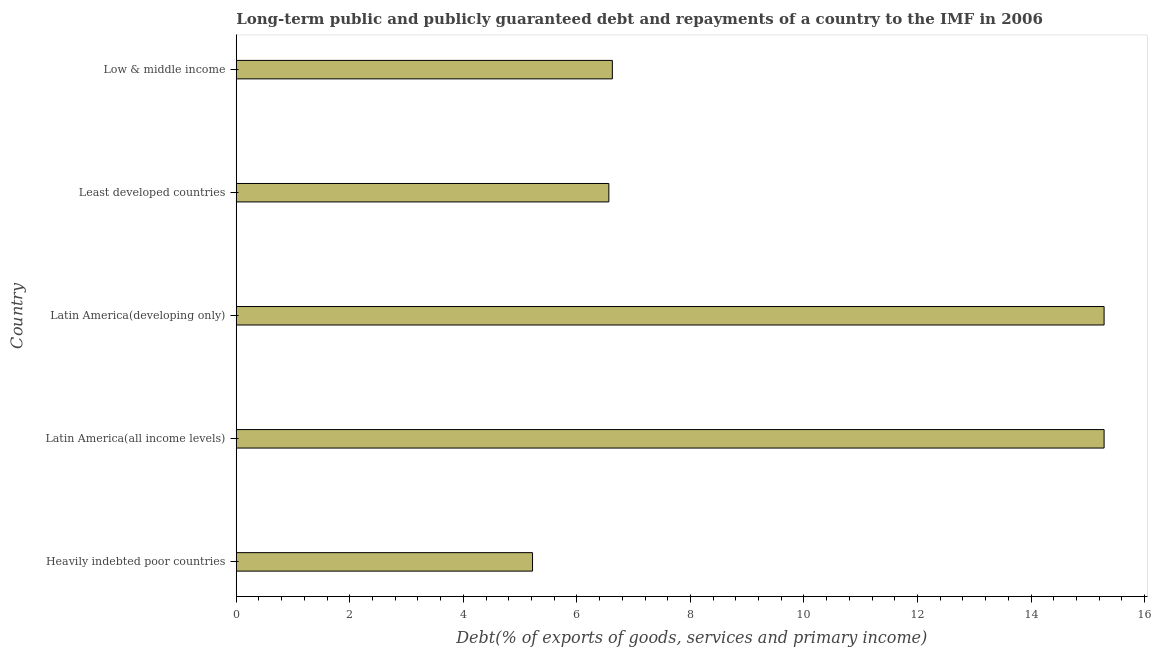What is the title of the graph?
Your answer should be compact. Long-term public and publicly guaranteed debt and repayments of a country to the IMF in 2006. What is the label or title of the X-axis?
Make the answer very short. Debt(% of exports of goods, services and primary income). What is the debt service in Heavily indebted poor countries?
Your answer should be very brief. 5.22. Across all countries, what is the maximum debt service?
Ensure brevity in your answer.  15.29. Across all countries, what is the minimum debt service?
Make the answer very short. 5.22. In which country was the debt service maximum?
Offer a terse response. Latin America(all income levels). In which country was the debt service minimum?
Your response must be concise. Heavily indebted poor countries. What is the sum of the debt service?
Give a very brief answer. 48.98. What is the average debt service per country?
Provide a short and direct response. 9.8. What is the median debt service?
Your answer should be compact. 6.62. What is the ratio of the debt service in Heavily indebted poor countries to that in Latin America(developing only)?
Keep it short and to the point. 0.34. Is the sum of the debt service in Heavily indebted poor countries and Latin America(all income levels) greater than the maximum debt service across all countries?
Ensure brevity in your answer.  Yes. What is the difference between the highest and the lowest debt service?
Ensure brevity in your answer.  10.07. In how many countries, is the debt service greater than the average debt service taken over all countries?
Ensure brevity in your answer.  2. How many bars are there?
Your answer should be compact. 5. How many countries are there in the graph?
Offer a very short reply. 5. What is the Debt(% of exports of goods, services and primary income) of Heavily indebted poor countries?
Give a very brief answer. 5.22. What is the Debt(% of exports of goods, services and primary income) of Latin America(all income levels)?
Provide a succinct answer. 15.29. What is the Debt(% of exports of goods, services and primary income) in Latin America(developing only)?
Keep it short and to the point. 15.29. What is the Debt(% of exports of goods, services and primary income) in Least developed countries?
Your response must be concise. 6.56. What is the Debt(% of exports of goods, services and primary income) in Low & middle income?
Offer a terse response. 6.62. What is the difference between the Debt(% of exports of goods, services and primary income) in Heavily indebted poor countries and Latin America(all income levels)?
Your response must be concise. -10.07. What is the difference between the Debt(% of exports of goods, services and primary income) in Heavily indebted poor countries and Latin America(developing only)?
Offer a terse response. -10.07. What is the difference between the Debt(% of exports of goods, services and primary income) in Heavily indebted poor countries and Least developed countries?
Your answer should be compact. -1.34. What is the difference between the Debt(% of exports of goods, services and primary income) in Heavily indebted poor countries and Low & middle income?
Provide a succinct answer. -1.41. What is the difference between the Debt(% of exports of goods, services and primary income) in Latin America(all income levels) and Latin America(developing only)?
Offer a very short reply. 0. What is the difference between the Debt(% of exports of goods, services and primary income) in Latin America(all income levels) and Least developed countries?
Make the answer very short. 8.72. What is the difference between the Debt(% of exports of goods, services and primary income) in Latin America(all income levels) and Low & middle income?
Offer a very short reply. 8.66. What is the difference between the Debt(% of exports of goods, services and primary income) in Latin America(developing only) and Least developed countries?
Offer a very short reply. 8.72. What is the difference between the Debt(% of exports of goods, services and primary income) in Latin America(developing only) and Low & middle income?
Make the answer very short. 8.66. What is the difference between the Debt(% of exports of goods, services and primary income) in Least developed countries and Low & middle income?
Offer a very short reply. -0.06. What is the ratio of the Debt(% of exports of goods, services and primary income) in Heavily indebted poor countries to that in Latin America(all income levels)?
Provide a succinct answer. 0.34. What is the ratio of the Debt(% of exports of goods, services and primary income) in Heavily indebted poor countries to that in Latin America(developing only)?
Make the answer very short. 0.34. What is the ratio of the Debt(% of exports of goods, services and primary income) in Heavily indebted poor countries to that in Least developed countries?
Give a very brief answer. 0.8. What is the ratio of the Debt(% of exports of goods, services and primary income) in Heavily indebted poor countries to that in Low & middle income?
Offer a terse response. 0.79. What is the ratio of the Debt(% of exports of goods, services and primary income) in Latin America(all income levels) to that in Least developed countries?
Your answer should be very brief. 2.33. What is the ratio of the Debt(% of exports of goods, services and primary income) in Latin America(all income levels) to that in Low & middle income?
Provide a succinct answer. 2.31. What is the ratio of the Debt(% of exports of goods, services and primary income) in Latin America(developing only) to that in Least developed countries?
Offer a very short reply. 2.33. What is the ratio of the Debt(% of exports of goods, services and primary income) in Latin America(developing only) to that in Low & middle income?
Give a very brief answer. 2.31. What is the ratio of the Debt(% of exports of goods, services and primary income) in Least developed countries to that in Low & middle income?
Your answer should be compact. 0.99. 